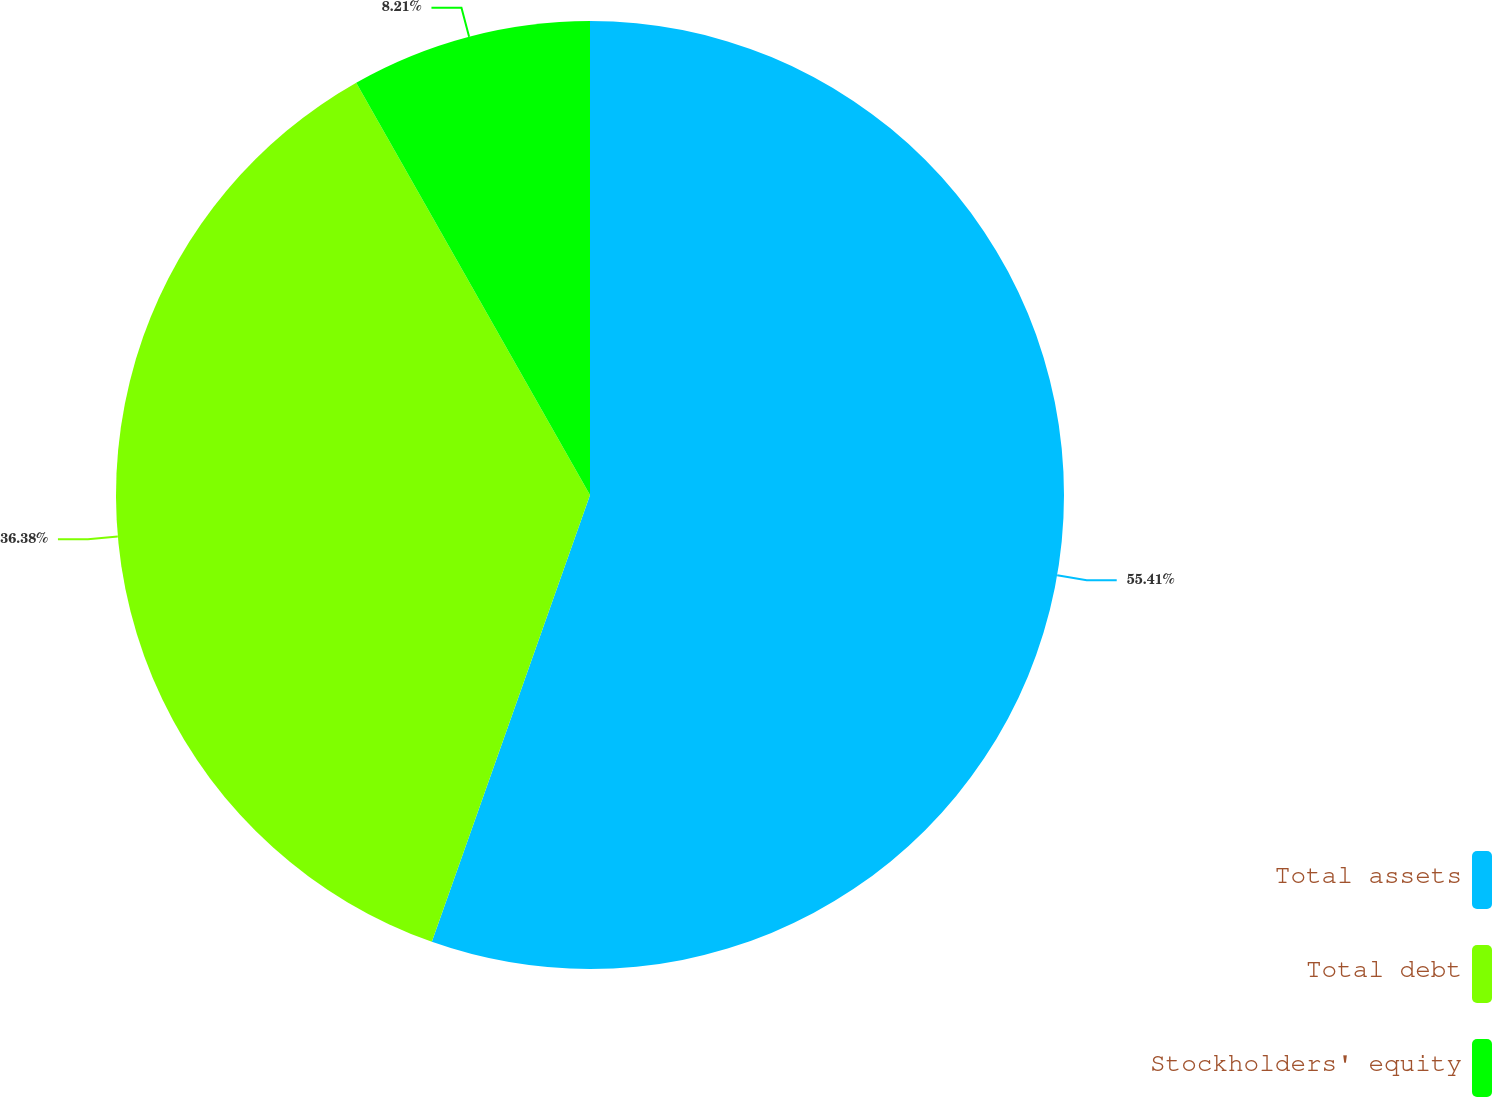Convert chart. <chart><loc_0><loc_0><loc_500><loc_500><pie_chart><fcel>Total assets<fcel>Total debt<fcel>Stockholders' equity<nl><fcel>55.42%<fcel>36.38%<fcel>8.21%<nl></chart> 